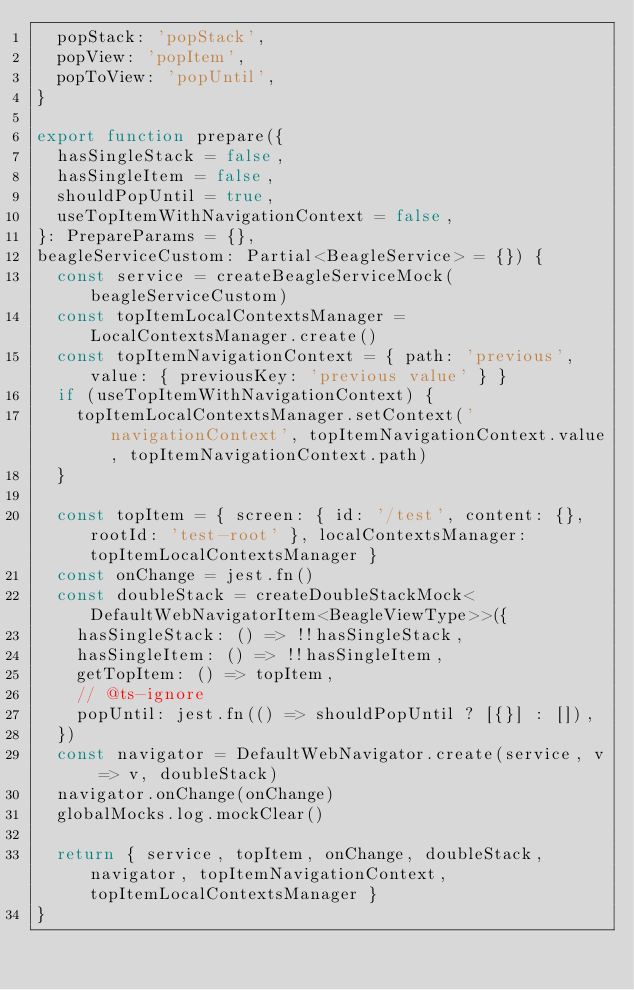Convert code to text. <code><loc_0><loc_0><loc_500><loc_500><_TypeScript_>  popStack: 'popStack',
  popView: 'popItem',
  popToView: 'popUntil',
}

export function prepare({
  hasSingleStack = false,
  hasSingleItem = false,
  shouldPopUntil = true,
  useTopItemWithNavigationContext = false,
}: PrepareParams = {},
beagleServiceCustom: Partial<BeagleService> = {}) {
  const service = createBeagleServiceMock(beagleServiceCustom)
  const topItemLocalContextsManager = LocalContextsManager.create()
  const topItemNavigationContext = { path: 'previous', value: { previousKey: 'previous value' } }
  if (useTopItemWithNavigationContext) {
    topItemLocalContextsManager.setContext('navigationContext', topItemNavigationContext.value, topItemNavigationContext.path)
  }

  const topItem = { screen: { id: '/test', content: {}, rootId: 'test-root' }, localContextsManager: topItemLocalContextsManager }
  const onChange = jest.fn()
  const doubleStack = createDoubleStackMock<DefaultWebNavigatorItem<BeagleViewType>>({
    hasSingleStack: () => !!hasSingleStack,
    hasSingleItem: () => !!hasSingleItem,
    getTopItem: () => topItem,
    // @ts-ignore
    popUntil: jest.fn(() => shouldPopUntil ? [{}] : []),
  })
  const navigator = DefaultWebNavigator.create(service, v => v, doubleStack)
  navigator.onChange(onChange)
  globalMocks.log.mockClear()

  return { service, topItem, onChange, doubleStack, navigator, topItemNavigationContext, topItemLocalContextsManager }
}
</code> 